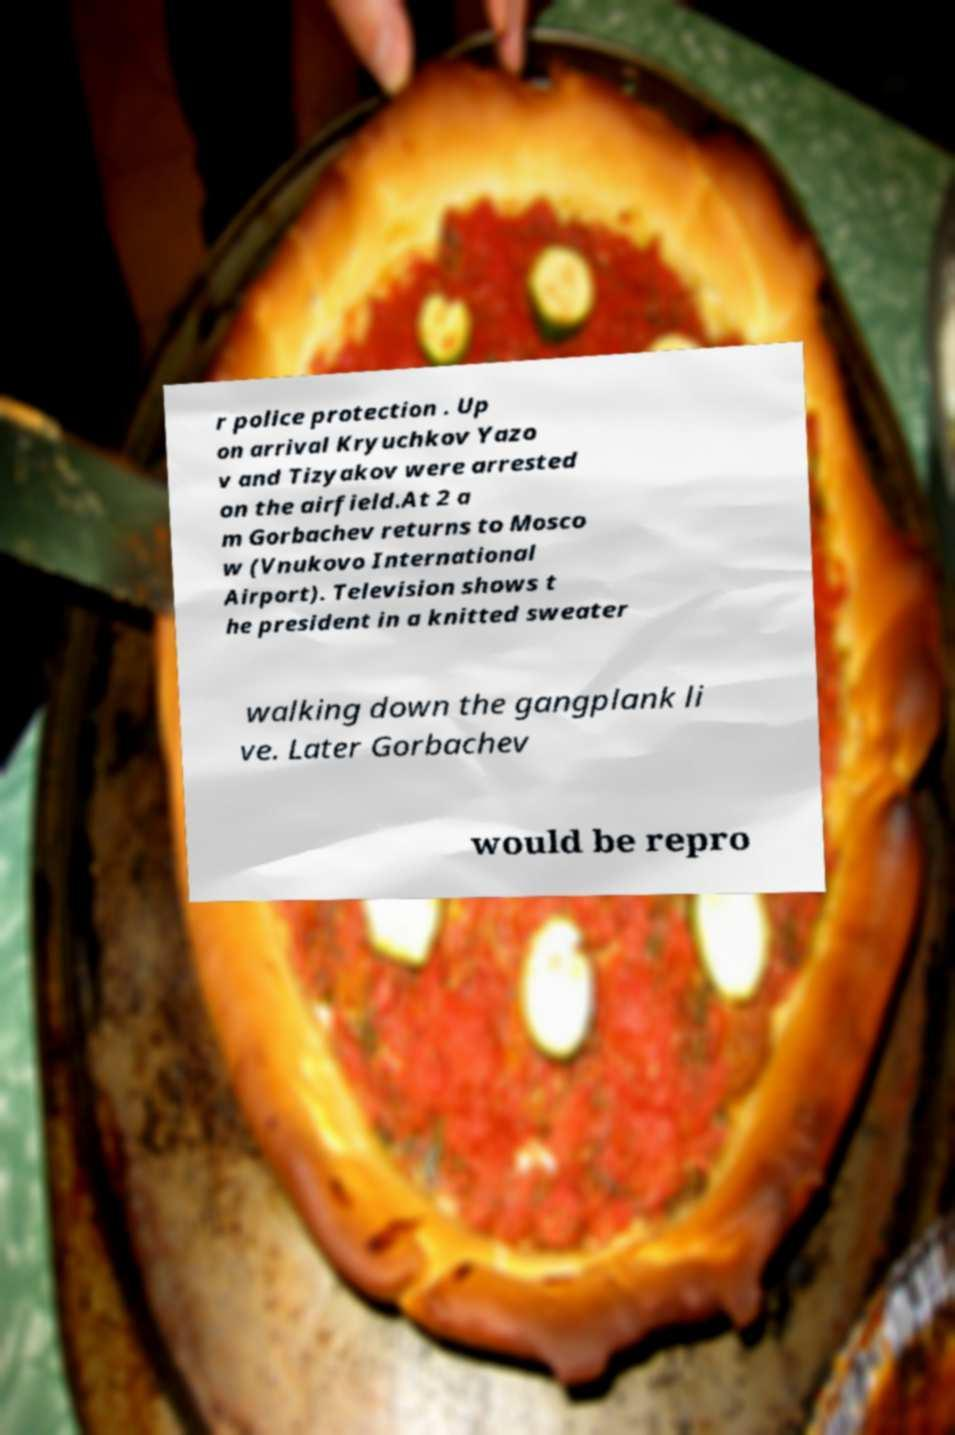Could you assist in decoding the text presented in this image and type it out clearly? r police protection . Up on arrival Kryuchkov Yazo v and Tizyakov were arrested on the airfield.At 2 a m Gorbachev returns to Mosco w (Vnukovo International Airport). Television shows t he president in a knitted sweater walking down the gangplank li ve. Later Gorbachev would be repro 